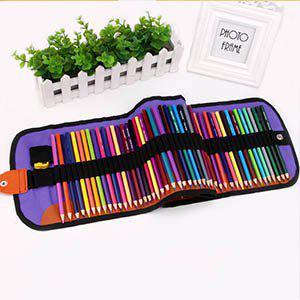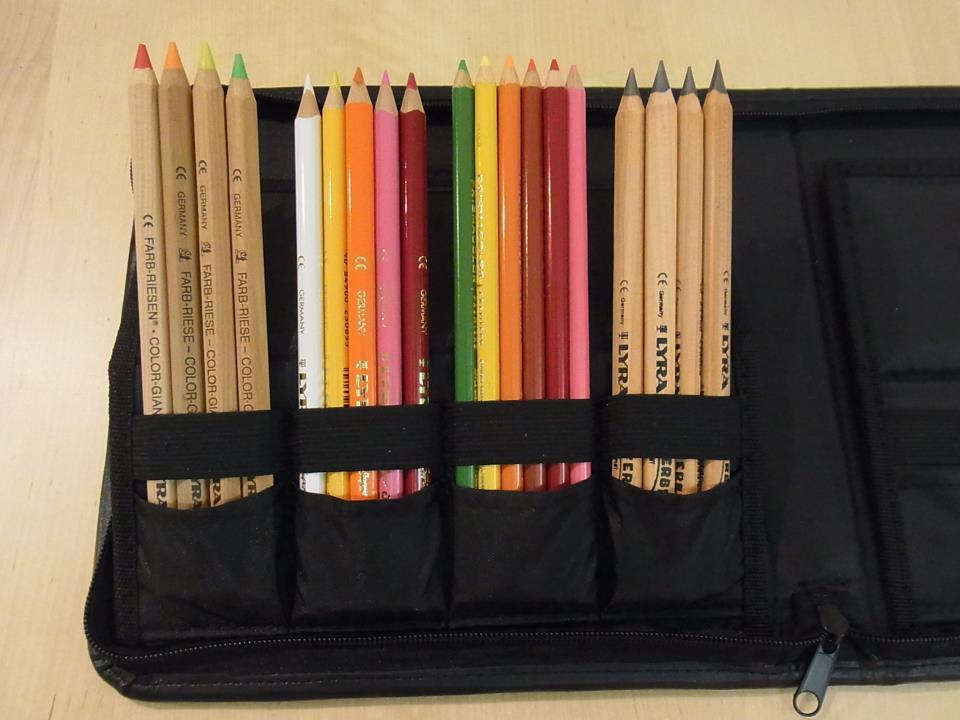The first image is the image on the left, the second image is the image on the right. Considering the images on both sides, is "Each image includes colored pencils, and at least one image shows an open pencil case that has a long black strap running its length to secure the pencils." valid? Answer yes or no. Yes. The first image is the image on the left, the second image is the image on the right. Given the left and right images, does the statement "Both images feature pencils strapped inside a case." hold true? Answer yes or no. Yes. 